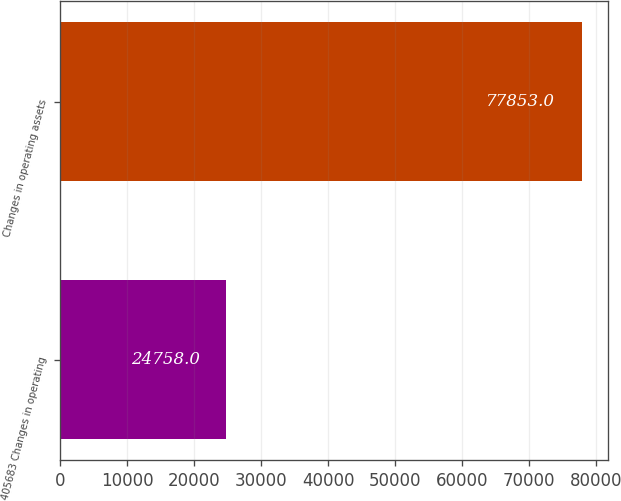Convert chart to OTSL. <chart><loc_0><loc_0><loc_500><loc_500><bar_chart><fcel>405683 Changes in operating<fcel>Changes in operating assets<nl><fcel>24758<fcel>77853<nl></chart> 